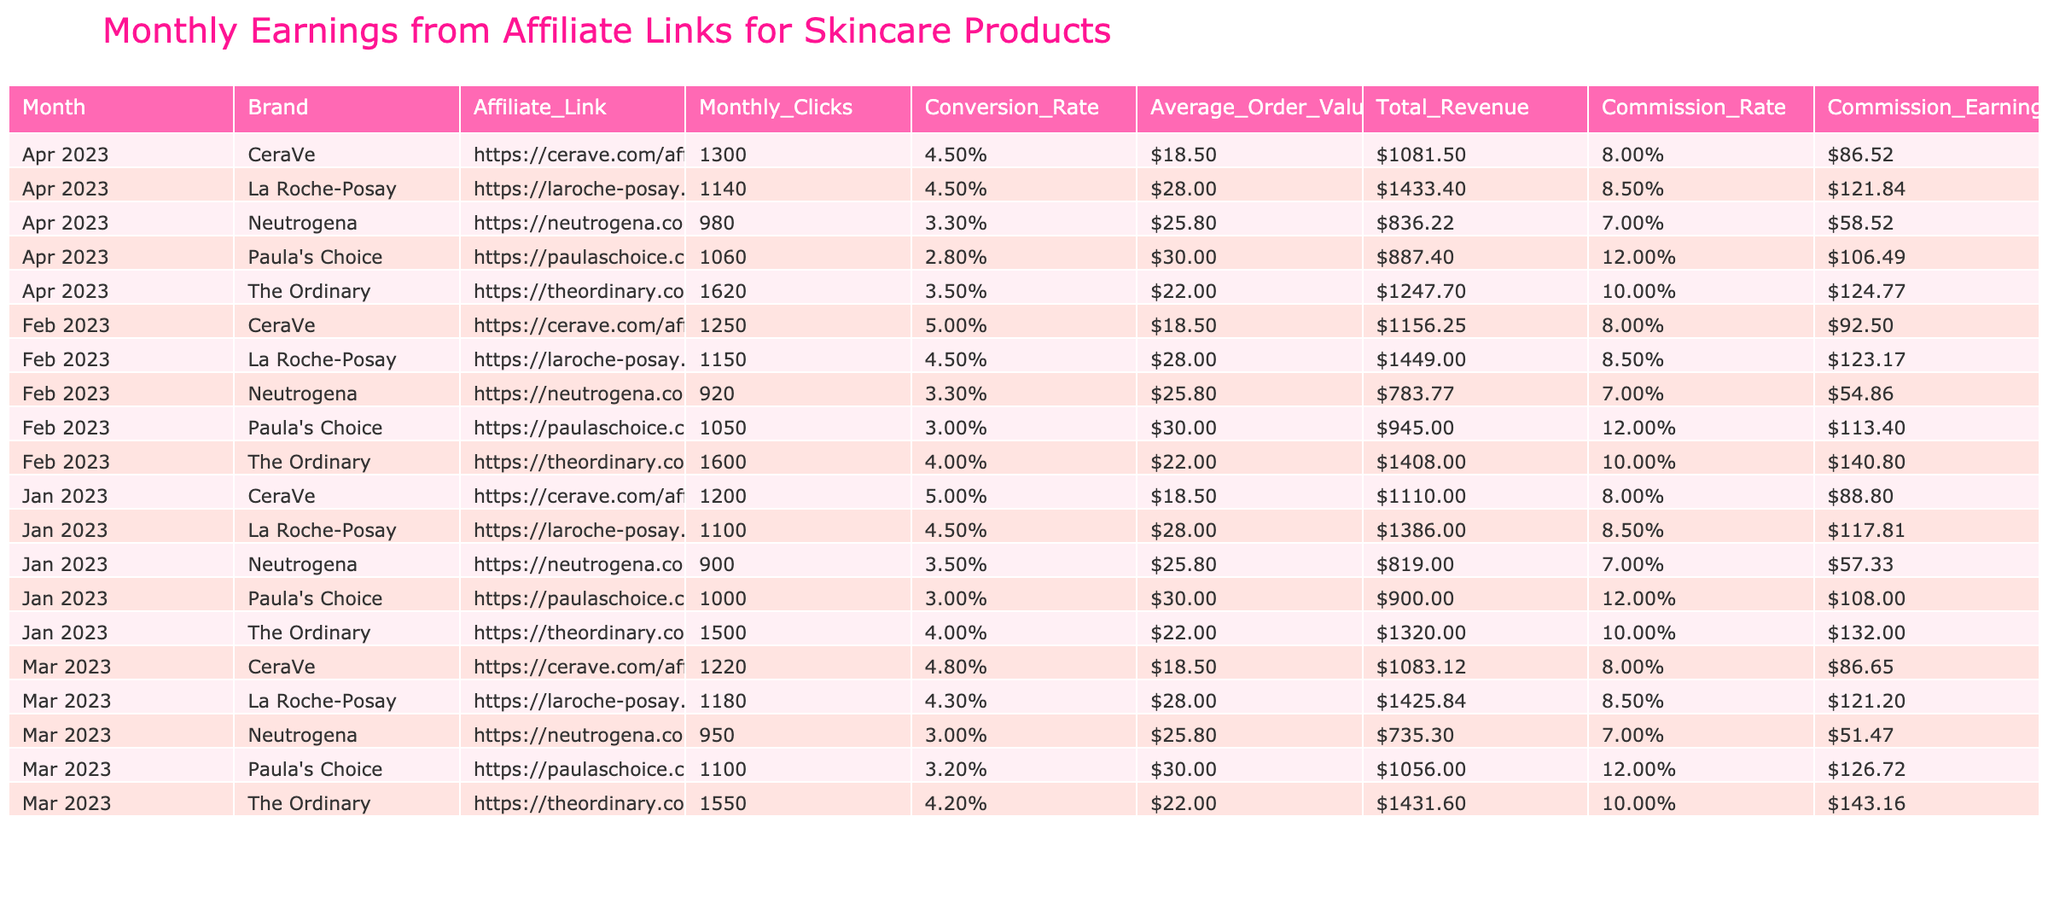What was the highest total revenue in January 2023? In January 2023, the total revenues for each brand are: The Ordinary - 1320.00, CeraVe - 1110.00, Neutrogena - 819.00, Paula's Choice - 900.00, and La Roche-Posay - 1386.00. The highest total revenue is 1386.00 from La Roche-Posay.
Answer: 1386.00 What is the average commission earnings for Paula's Choice across the four months? Paula's Choice commission earnings are: January - 108.00, February - 113.40, March - 126.72, and April - 106.49. To find the average, sum these values: 108.00 + 113.40 + 126.72 + 106.49 = 454.61, and then divide by 4, which is 454.61 / 4 = 113.65.
Answer: 113.65 Did CeraVe have a higher commission rate than La Roche-Posay in April 2023? In April 2023, CeraVe's commission rate is 0.08 (8%), and La Roche-Posay's commission rate is 0.085 (8.5%). Since 8.5% is greater than 8%, CeraVe did not have a higher commission rate.
Answer: No What is the total number of clicks across all brands in February 2023? In February 2023, the monthly clicks for each brand are: The Ordinary - 1600, CeraVe - 1250, Neutrogena - 920, Paula's Choice - 1050, and La Roche-Posay - 1150. Summing these values gives 1600 + 1250 + 920 + 1050 + 1150 = 4970.
Answer: 4970 Which brand generated the least commission earnings in March 2023? In March 2023, the commission earnings for each brand are: The Ordinary - 143.16, CeraVe - 86.65, Neutrogena - 51.47, Paula's Choice - 126.72, and La Roche-Posay - 121.20. The least commission earnings were from Neutrogena at 51.47.
Answer: Neutrogena 